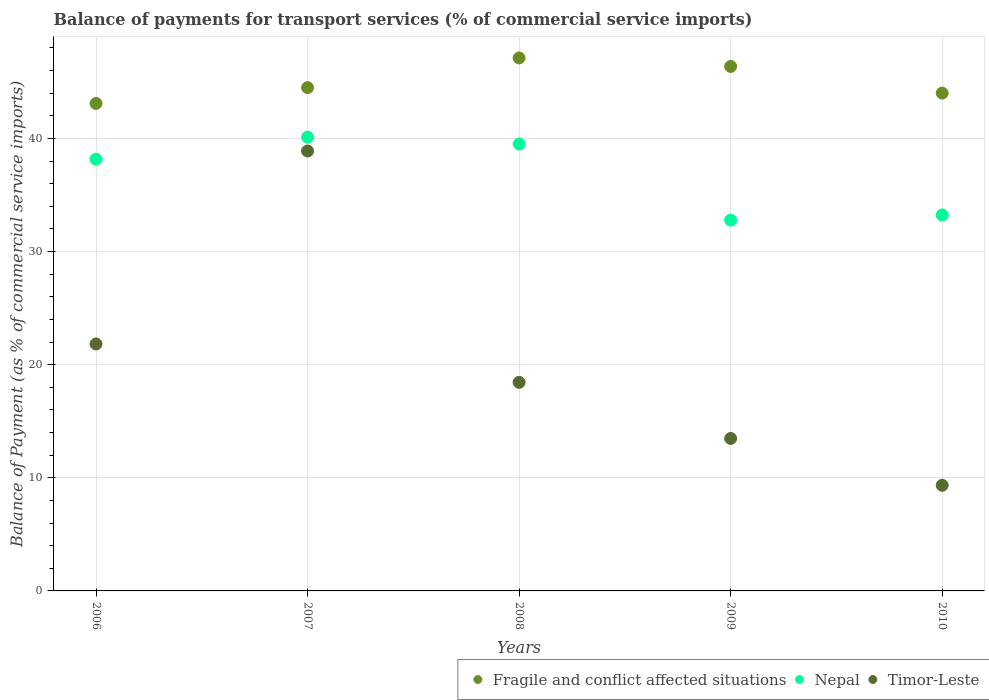What is the balance of payments for transport services in Fragile and conflict affected situations in 2010?
Provide a succinct answer. 44. Across all years, what is the maximum balance of payments for transport services in Fragile and conflict affected situations?
Give a very brief answer. 47.11. Across all years, what is the minimum balance of payments for transport services in Fragile and conflict affected situations?
Offer a terse response. 43.09. What is the total balance of payments for transport services in Timor-Leste in the graph?
Your response must be concise. 101.97. What is the difference between the balance of payments for transport services in Timor-Leste in 2006 and that in 2007?
Your answer should be very brief. -17.06. What is the difference between the balance of payments for transport services in Nepal in 2006 and the balance of payments for transport services in Fragile and conflict affected situations in 2010?
Give a very brief answer. -5.84. What is the average balance of payments for transport services in Timor-Leste per year?
Keep it short and to the point. 20.39. In the year 2010, what is the difference between the balance of payments for transport services in Timor-Leste and balance of payments for transport services in Fragile and conflict affected situations?
Your answer should be very brief. -34.67. What is the ratio of the balance of payments for transport services in Nepal in 2006 to that in 2007?
Give a very brief answer. 0.95. Is the difference between the balance of payments for transport services in Timor-Leste in 2007 and 2008 greater than the difference between the balance of payments for transport services in Fragile and conflict affected situations in 2007 and 2008?
Provide a short and direct response. Yes. What is the difference between the highest and the second highest balance of payments for transport services in Timor-Leste?
Make the answer very short. 17.06. What is the difference between the highest and the lowest balance of payments for transport services in Nepal?
Your response must be concise. 7.34. In how many years, is the balance of payments for transport services in Nepal greater than the average balance of payments for transport services in Nepal taken over all years?
Provide a short and direct response. 3. Is it the case that in every year, the sum of the balance of payments for transport services in Timor-Leste and balance of payments for transport services in Nepal  is greater than the balance of payments for transport services in Fragile and conflict affected situations?
Provide a short and direct response. No. Does the balance of payments for transport services in Fragile and conflict affected situations monotonically increase over the years?
Make the answer very short. No. Is the balance of payments for transport services in Timor-Leste strictly less than the balance of payments for transport services in Nepal over the years?
Make the answer very short. Yes. What is the difference between two consecutive major ticks on the Y-axis?
Offer a terse response. 10. Are the values on the major ticks of Y-axis written in scientific E-notation?
Ensure brevity in your answer.  No. Does the graph contain any zero values?
Your answer should be compact. No. Does the graph contain grids?
Offer a terse response. Yes. Where does the legend appear in the graph?
Provide a short and direct response. Bottom right. What is the title of the graph?
Your answer should be compact. Balance of payments for transport services (% of commercial service imports). Does "Qatar" appear as one of the legend labels in the graph?
Make the answer very short. No. What is the label or title of the X-axis?
Your answer should be very brief. Years. What is the label or title of the Y-axis?
Make the answer very short. Balance of Payment (as % of commercial service imports). What is the Balance of Payment (as % of commercial service imports) of Fragile and conflict affected situations in 2006?
Keep it short and to the point. 43.09. What is the Balance of Payment (as % of commercial service imports) of Nepal in 2006?
Offer a terse response. 38.16. What is the Balance of Payment (as % of commercial service imports) of Timor-Leste in 2006?
Your answer should be very brief. 21.83. What is the Balance of Payment (as % of commercial service imports) of Fragile and conflict affected situations in 2007?
Your answer should be very brief. 44.49. What is the Balance of Payment (as % of commercial service imports) of Nepal in 2007?
Provide a short and direct response. 40.12. What is the Balance of Payment (as % of commercial service imports) in Timor-Leste in 2007?
Your response must be concise. 38.89. What is the Balance of Payment (as % of commercial service imports) of Fragile and conflict affected situations in 2008?
Give a very brief answer. 47.11. What is the Balance of Payment (as % of commercial service imports) of Nepal in 2008?
Ensure brevity in your answer.  39.51. What is the Balance of Payment (as % of commercial service imports) of Timor-Leste in 2008?
Your response must be concise. 18.44. What is the Balance of Payment (as % of commercial service imports) of Fragile and conflict affected situations in 2009?
Provide a short and direct response. 46.36. What is the Balance of Payment (as % of commercial service imports) in Nepal in 2009?
Offer a terse response. 32.78. What is the Balance of Payment (as % of commercial service imports) of Timor-Leste in 2009?
Your answer should be compact. 13.48. What is the Balance of Payment (as % of commercial service imports) in Fragile and conflict affected situations in 2010?
Offer a very short reply. 44. What is the Balance of Payment (as % of commercial service imports) of Nepal in 2010?
Your response must be concise. 33.23. What is the Balance of Payment (as % of commercial service imports) of Timor-Leste in 2010?
Provide a succinct answer. 9.34. Across all years, what is the maximum Balance of Payment (as % of commercial service imports) in Fragile and conflict affected situations?
Ensure brevity in your answer.  47.11. Across all years, what is the maximum Balance of Payment (as % of commercial service imports) in Nepal?
Offer a very short reply. 40.12. Across all years, what is the maximum Balance of Payment (as % of commercial service imports) in Timor-Leste?
Give a very brief answer. 38.89. Across all years, what is the minimum Balance of Payment (as % of commercial service imports) in Fragile and conflict affected situations?
Provide a short and direct response. 43.09. Across all years, what is the minimum Balance of Payment (as % of commercial service imports) of Nepal?
Keep it short and to the point. 32.78. Across all years, what is the minimum Balance of Payment (as % of commercial service imports) in Timor-Leste?
Your response must be concise. 9.34. What is the total Balance of Payment (as % of commercial service imports) of Fragile and conflict affected situations in the graph?
Your answer should be very brief. 225.07. What is the total Balance of Payment (as % of commercial service imports) of Nepal in the graph?
Provide a succinct answer. 183.81. What is the total Balance of Payment (as % of commercial service imports) in Timor-Leste in the graph?
Provide a short and direct response. 101.97. What is the difference between the Balance of Payment (as % of commercial service imports) in Fragile and conflict affected situations in 2006 and that in 2007?
Keep it short and to the point. -1.4. What is the difference between the Balance of Payment (as % of commercial service imports) in Nepal in 2006 and that in 2007?
Your answer should be compact. -1.96. What is the difference between the Balance of Payment (as % of commercial service imports) of Timor-Leste in 2006 and that in 2007?
Offer a terse response. -17.06. What is the difference between the Balance of Payment (as % of commercial service imports) of Fragile and conflict affected situations in 2006 and that in 2008?
Make the answer very short. -4.02. What is the difference between the Balance of Payment (as % of commercial service imports) of Nepal in 2006 and that in 2008?
Offer a terse response. -1.34. What is the difference between the Balance of Payment (as % of commercial service imports) of Timor-Leste in 2006 and that in 2008?
Ensure brevity in your answer.  3.39. What is the difference between the Balance of Payment (as % of commercial service imports) of Fragile and conflict affected situations in 2006 and that in 2009?
Provide a short and direct response. -3.27. What is the difference between the Balance of Payment (as % of commercial service imports) in Nepal in 2006 and that in 2009?
Offer a terse response. 5.38. What is the difference between the Balance of Payment (as % of commercial service imports) in Timor-Leste in 2006 and that in 2009?
Make the answer very short. 8.35. What is the difference between the Balance of Payment (as % of commercial service imports) of Fragile and conflict affected situations in 2006 and that in 2010?
Your response must be concise. -0.91. What is the difference between the Balance of Payment (as % of commercial service imports) of Nepal in 2006 and that in 2010?
Offer a very short reply. 4.93. What is the difference between the Balance of Payment (as % of commercial service imports) of Timor-Leste in 2006 and that in 2010?
Make the answer very short. 12.49. What is the difference between the Balance of Payment (as % of commercial service imports) of Fragile and conflict affected situations in 2007 and that in 2008?
Your answer should be compact. -2.62. What is the difference between the Balance of Payment (as % of commercial service imports) in Nepal in 2007 and that in 2008?
Offer a very short reply. 0.62. What is the difference between the Balance of Payment (as % of commercial service imports) in Timor-Leste in 2007 and that in 2008?
Make the answer very short. 20.45. What is the difference between the Balance of Payment (as % of commercial service imports) of Fragile and conflict affected situations in 2007 and that in 2009?
Offer a terse response. -1.87. What is the difference between the Balance of Payment (as % of commercial service imports) of Nepal in 2007 and that in 2009?
Provide a short and direct response. 7.34. What is the difference between the Balance of Payment (as % of commercial service imports) of Timor-Leste in 2007 and that in 2009?
Provide a short and direct response. 25.41. What is the difference between the Balance of Payment (as % of commercial service imports) in Fragile and conflict affected situations in 2007 and that in 2010?
Give a very brief answer. 0.49. What is the difference between the Balance of Payment (as % of commercial service imports) in Nepal in 2007 and that in 2010?
Make the answer very short. 6.89. What is the difference between the Balance of Payment (as % of commercial service imports) of Timor-Leste in 2007 and that in 2010?
Ensure brevity in your answer.  29.55. What is the difference between the Balance of Payment (as % of commercial service imports) in Nepal in 2008 and that in 2009?
Offer a very short reply. 6.73. What is the difference between the Balance of Payment (as % of commercial service imports) of Timor-Leste in 2008 and that in 2009?
Provide a short and direct response. 4.96. What is the difference between the Balance of Payment (as % of commercial service imports) of Fragile and conflict affected situations in 2008 and that in 2010?
Offer a terse response. 3.11. What is the difference between the Balance of Payment (as % of commercial service imports) of Nepal in 2008 and that in 2010?
Your answer should be compact. 6.28. What is the difference between the Balance of Payment (as % of commercial service imports) of Timor-Leste in 2008 and that in 2010?
Offer a terse response. 9.1. What is the difference between the Balance of Payment (as % of commercial service imports) in Fragile and conflict affected situations in 2009 and that in 2010?
Provide a succinct answer. 2.36. What is the difference between the Balance of Payment (as % of commercial service imports) in Nepal in 2009 and that in 2010?
Offer a very short reply. -0.45. What is the difference between the Balance of Payment (as % of commercial service imports) of Timor-Leste in 2009 and that in 2010?
Offer a terse response. 4.14. What is the difference between the Balance of Payment (as % of commercial service imports) in Fragile and conflict affected situations in 2006 and the Balance of Payment (as % of commercial service imports) in Nepal in 2007?
Ensure brevity in your answer.  2.97. What is the difference between the Balance of Payment (as % of commercial service imports) of Fragile and conflict affected situations in 2006 and the Balance of Payment (as % of commercial service imports) of Timor-Leste in 2007?
Provide a short and direct response. 4.2. What is the difference between the Balance of Payment (as % of commercial service imports) in Nepal in 2006 and the Balance of Payment (as % of commercial service imports) in Timor-Leste in 2007?
Offer a terse response. -0.72. What is the difference between the Balance of Payment (as % of commercial service imports) of Fragile and conflict affected situations in 2006 and the Balance of Payment (as % of commercial service imports) of Nepal in 2008?
Keep it short and to the point. 3.59. What is the difference between the Balance of Payment (as % of commercial service imports) of Fragile and conflict affected situations in 2006 and the Balance of Payment (as % of commercial service imports) of Timor-Leste in 2008?
Give a very brief answer. 24.66. What is the difference between the Balance of Payment (as % of commercial service imports) of Nepal in 2006 and the Balance of Payment (as % of commercial service imports) of Timor-Leste in 2008?
Provide a succinct answer. 19.73. What is the difference between the Balance of Payment (as % of commercial service imports) in Fragile and conflict affected situations in 2006 and the Balance of Payment (as % of commercial service imports) in Nepal in 2009?
Provide a short and direct response. 10.31. What is the difference between the Balance of Payment (as % of commercial service imports) of Fragile and conflict affected situations in 2006 and the Balance of Payment (as % of commercial service imports) of Timor-Leste in 2009?
Your answer should be compact. 29.61. What is the difference between the Balance of Payment (as % of commercial service imports) of Nepal in 2006 and the Balance of Payment (as % of commercial service imports) of Timor-Leste in 2009?
Offer a terse response. 24.69. What is the difference between the Balance of Payment (as % of commercial service imports) in Fragile and conflict affected situations in 2006 and the Balance of Payment (as % of commercial service imports) in Nepal in 2010?
Offer a very short reply. 9.86. What is the difference between the Balance of Payment (as % of commercial service imports) of Fragile and conflict affected situations in 2006 and the Balance of Payment (as % of commercial service imports) of Timor-Leste in 2010?
Keep it short and to the point. 33.76. What is the difference between the Balance of Payment (as % of commercial service imports) of Nepal in 2006 and the Balance of Payment (as % of commercial service imports) of Timor-Leste in 2010?
Provide a short and direct response. 28.83. What is the difference between the Balance of Payment (as % of commercial service imports) in Fragile and conflict affected situations in 2007 and the Balance of Payment (as % of commercial service imports) in Nepal in 2008?
Offer a terse response. 4.98. What is the difference between the Balance of Payment (as % of commercial service imports) of Fragile and conflict affected situations in 2007 and the Balance of Payment (as % of commercial service imports) of Timor-Leste in 2008?
Keep it short and to the point. 26.05. What is the difference between the Balance of Payment (as % of commercial service imports) of Nepal in 2007 and the Balance of Payment (as % of commercial service imports) of Timor-Leste in 2008?
Give a very brief answer. 21.69. What is the difference between the Balance of Payment (as % of commercial service imports) of Fragile and conflict affected situations in 2007 and the Balance of Payment (as % of commercial service imports) of Nepal in 2009?
Make the answer very short. 11.71. What is the difference between the Balance of Payment (as % of commercial service imports) in Fragile and conflict affected situations in 2007 and the Balance of Payment (as % of commercial service imports) in Timor-Leste in 2009?
Your answer should be very brief. 31.01. What is the difference between the Balance of Payment (as % of commercial service imports) in Nepal in 2007 and the Balance of Payment (as % of commercial service imports) in Timor-Leste in 2009?
Make the answer very short. 26.64. What is the difference between the Balance of Payment (as % of commercial service imports) of Fragile and conflict affected situations in 2007 and the Balance of Payment (as % of commercial service imports) of Nepal in 2010?
Give a very brief answer. 11.26. What is the difference between the Balance of Payment (as % of commercial service imports) in Fragile and conflict affected situations in 2007 and the Balance of Payment (as % of commercial service imports) in Timor-Leste in 2010?
Provide a succinct answer. 35.15. What is the difference between the Balance of Payment (as % of commercial service imports) of Nepal in 2007 and the Balance of Payment (as % of commercial service imports) of Timor-Leste in 2010?
Keep it short and to the point. 30.79. What is the difference between the Balance of Payment (as % of commercial service imports) in Fragile and conflict affected situations in 2008 and the Balance of Payment (as % of commercial service imports) in Nepal in 2009?
Ensure brevity in your answer.  14.33. What is the difference between the Balance of Payment (as % of commercial service imports) of Fragile and conflict affected situations in 2008 and the Balance of Payment (as % of commercial service imports) of Timor-Leste in 2009?
Offer a terse response. 33.64. What is the difference between the Balance of Payment (as % of commercial service imports) of Nepal in 2008 and the Balance of Payment (as % of commercial service imports) of Timor-Leste in 2009?
Provide a succinct answer. 26.03. What is the difference between the Balance of Payment (as % of commercial service imports) of Fragile and conflict affected situations in 2008 and the Balance of Payment (as % of commercial service imports) of Nepal in 2010?
Your response must be concise. 13.88. What is the difference between the Balance of Payment (as % of commercial service imports) of Fragile and conflict affected situations in 2008 and the Balance of Payment (as % of commercial service imports) of Timor-Leste in 2010?
Your response must be concise. 37.78. What is the difference between the Balance of Payment (as % of commercial service imports) of Nepal in 2008 and the Balance of Payment (as % of commercial service imports) of Timor-Leste in 2010?
Provide a short and direct response. 30.17. What is the difference between the Balance of Payment (as % of commercial service imports) of Fragile and conflict affected situations in 2009 and the Balance of Payment (as % of commercial service imports) of Nepal in 2010?
Provide a short and direct response. 13.13. What is the difference between the Balance of Payment (as % of commercial service imports) in Fragile and conflict affected situations in 2009 and the Balance of Payment (as % of commercial service imports) in Timor-Leste in 2010?
Your answer should be very brief. 37.03. What is the difference between the Balance of Payment (as % of commercial service imports) of Nepal in 2009 and the Balance of Payment (as % of commercial service imports) of Timor-Leste in 2010?
Give a very brief answer. 23.44. What is the average Balance of Payment (as % of commercial service imports) of Fragile and conflict affected situations per year?
Your answer should be very brief. 45.01. What is the average Balance of Payment (as % of commercial service imports) of Nepal per year?
Provide a succinct answer. 36.76. What is the average Balance of Payment (as % of commercial service imports) of Timor-Leste per year?
Make the answer very short. 20.39. In the year 2006, what is the difference between the Balance of Payment (as % of commercial service imports) of Fragile and conflict affected situations and Balance of Payment (as % of commercial service imports) of Nepal?
Provide a succinct answer. 4.93. In the year 2006, what is the difference between the Balance of Payment (as % of commercial service imports) in Fragile and conflict affected situations and Balance of Payment (as % of commercial service imports) in Timor-Leste?
Keep it short and to the point. 21.26. In the year 2006, what is the difference between the Balance of Payment (as % of commercial service imports) in Nepal and Balance of Payment (as % of commercial service imports) in Timor-Leste?
Make the answer very short. 16.33. In the year 2007, what is the difference between the Balance of Payment (as % of commercial service imports) in Fragile and conflict affected situations and Balance of Payment (as % of commercial service imports) in Nepal?
Provide a short and direct response. 4.37. In the year 2007, what is the difference between the Balance of Payment (as % of commercial service imports) of Fragile and conflict affected situations and Balance of Payment (as % of commercial service imports) of Timor-Leste?
Keep it short and to the point. 5.6. In the year 2007, what is the difference between the Balance of Payment (as % of commercial service imports) in Nepal and Balance of Payment (as % of commercial service imports) in Timor-Leste?
Ensure brevity in your answer.  1.23. In the year 2008, what is the difference between the Balance of Payment (as % of commercial service imports) of Fragile and conflict affected situations and Balance of Payment (as % of commercial service imports) of Nepal?
Provide a short and direct response. 7.61. In the year 2008, what is the difference between the Balance of Payment (as % of commercial service imports) of Fragile and conflict affected situations and Balance of Payment (as % of commercial service imports) of Timor-Leste?
Offer a very short reply. 28.68. In the year 2008, what is the difference between the Balance of Payment (as % of commercial service imports) in Nepal and Balance of Payment (as % of commercial service imports) in Timor-Leste?
Keep it short and to the point. 21.07. In the year 2009, what is the difference between the Balance of Payment (as % of commercial service imports) in Fragile and conflict affected situations and Balance of Payment (as % of commercial service imports) in Nepal?
Provide a succinct answer. 13.58. In the year 2009, what is the difference between the Balance of Payment (as % of commercial service imports) of Fragile and conflict affected situations and Balance of Payment (as % of commercial service imports) of Timor-Leste?
Offer a terse response. 32.89. In the year 2009, what is the difference between the Balance of Payment (as % of commercial service imports) of Nepal and Balance of Payment (as % of commercial service imports) of Timor-Leste?
Offer a very short reply. 19.3. In the year 2010, what is the difference between the Balance of Payment (as % of commercial service imports) of Fragile and conflict affected situations and Balance of Payment (as % of commercial service imports) of Nepal?
Give a very brief answer. 10.77. In the year 2010, what is the difference between the Balance of Payment (as % of commercial service imports) in Fragile and conflict affected situations and Balance of Payment (as % of commercial service imports) in Timor-Leste?
Offer a very short reply. 34.67. In the year 2010, what is the difference between the Balance of Payment (as % of commercial service imports) in Nepal and Balance of Payment (as % of commercial service imports) in Timor-Leste?
Your answer should be very brief. 23.89. What is the ratio of the Balance of Payment (as % of commercial service imports) of Fragile and conflict affected situations in 2006 to that in 2007?
Offer a very short reply. 0.97. What is the ratio of the Balance of Payment (as % of commercial service imports) in Nepal in 2006 to that in 2007?
Your response must be concise. 0.95. What is the ratio of the Balance of Payment (as % of commercial service imports) of Timor-Leste in 2006 to that in 2007?
Keep it short and to the point. 0.56. What is the ratio of the Balance of Payment (as % of commercial service imports) of Fragile and conflict affected situations in 2006 to that in 2008?
Offer a terse response. 0.91. What is the ratio of the Balance of Payment (as % of commercial service imports) in Nepal in 2006 to that in 2008?
Provide a short and direct response. 0.97. What is the ratio of the Balance of Payment (as % of commercial service imports) of Timor-Leste in 2006 to that in 2008?
Your answer should be compact. 1.18. What is the ratio of the Balance of Payment (as % of commercial service imports) in Fragile and conflict affected situations in 2006 to that in 2009?
Your answer should be very brief. 0.93. What is the ratio of the Balance of Payment (as % of commercial service imports) in Nepal in 2006 to that in 2009?
Your response must be concise. 1.16. What is the ratio of the Balance of Payment (as % of commercial service imports) in Timor-Leste in 2006 to that in 2009?
Provide a succinct answer. 1.62. What is the ratio of the Balance of Payment (as % of commercial service imports) of Fragile and conflict affected situations in 2006 to that in 2010?
Keep it short and to the point. 0.98. What is the ratio of the Balance of Payment (as % of commercial service imports) of Nepal in 2006 to that in 2010?
Keep it short and to the point. 1.15. What is the ratio of the Balance of Payment (as % of commercial service imports) in Timor-Leste in 2006 to that in 2010?
Your answer should be very brief. 2.34. What is the ratio of the Balance of Payment (as % of commercial service imports) of Fragile and conflict affected situations in 2007 to that in 2008?
Your response must be concise. 0.94. What is the ratio of the Balance of Payment (as % of commercial service imports) in Nepal in 2007 to that in 2008?
Provide a short and direct response. 1.02. What is the ratio of the Balance of Payment (as % of commercial service imports) of Timor-Leste in 2007 to that in 2008?
Your answer should be compact. 2.11. What is the ratio of the Balance of Payment (as % of commercial service imports) of Fragile and conflict affected situations in 2007 to that in 2009?
Make the answer very short. 0.96. What is the ratio of the Balance of Payment (as % of commercial service imports) in Nepal in 2007 to that in 2009?
Provide a short and direct response. 1.22. What is the ratio of the Balance of Payment (as % of commercial service imports) of Timor-Leste in 2007 to that in 2009?
Your answer should be very brief. 2.89. What is the ratio of the Balance of Payment (as % of commercial service imports) in Fragile and conflict affected situations in 2007 to that in 2010?
Make the answer very short. 1.01. What is the ratio of the Balance of Payment (as % of commercial service imports) of Nepal in 2007 to that in 2010?
Provide a succinct answer. 1.21. What is the ratio of the Balance of Payment (as % of commercial service imports) in Timor-Leste in 2007 to that in 2010?
Your answer should be very brief. 4.16. What is the ratio of the Balance of Payment (as % of commercial service imports) in Fragile and conflict affected situations in 2008 to that in 2009?
Provide a short and direct response. 1.02. What is the ratio of the Balance of Payment (as % of commercial service imports) of Nepal in 2008 to that in 2009?
Provide a succinct answer. 1.21. What is the ratio of the Balance of Payment (as % of commercial service imports) in Timor-Leste in 2008 to that in 2009?
Provide a succinct answer. 1.37. What is the ratio of the Balance of Payment (as % of commercial service imports) of Fragile and conflict affected situations in 2008 to that in 2010?
Make the answer very short. 1.07. What is the ratio of the Balance of Payment (as % of commercial service imports) of Nepal in 2008 to that in 2010?
Your answer should be very brief. 1.19. What is the ratio of the Balance of Payment (as % of commercial service imports) in Timor-Leste in 2008 to that in 2010?
Your response must be concise. 1.97. What is the ratio of the Balance of Payment (as % of commercial service imports) in Fragile and conflict affected situations in 2009 to that in 2010?
Offer a terse response. 1.05. What is the ratio of the Balance of Payment (as % of commercial service imports) in Nepal in 2009 to that in 2010?
Your answer should be very brief. 0.99. What is the ratio of the Balance of Payment (as % of commercial service imports) of Timor-Leste in 2009 to that in 2010?
Give a very brief answer. 1.44. What is the difference between the highest and the second highest Balance of Payment (as % of commercial service imports) of Nepal?
Give a very brief answer. 0.62. What is the difference between the highest and the second highest Balance of Payment (as % of commercial service imports) in Timor-Leste?
Your response must be concise. 17.06. What is the difference between the highest and the lowest Balance of Payment (as % of commercial service imports) of Fragile and conflict affected situations?
Provide a succinct answer. 4.02. What is the difference between the highest and the lowest Balance of Payment (as % of commercial service imports) of Nepal?
Ensure brevity in your answer.  7.34. What is the difference between the highest and the lowest Balance of Payment (as % of commercial service imports) of Timor-Leste?
Offer a very short reply. 29.55. 